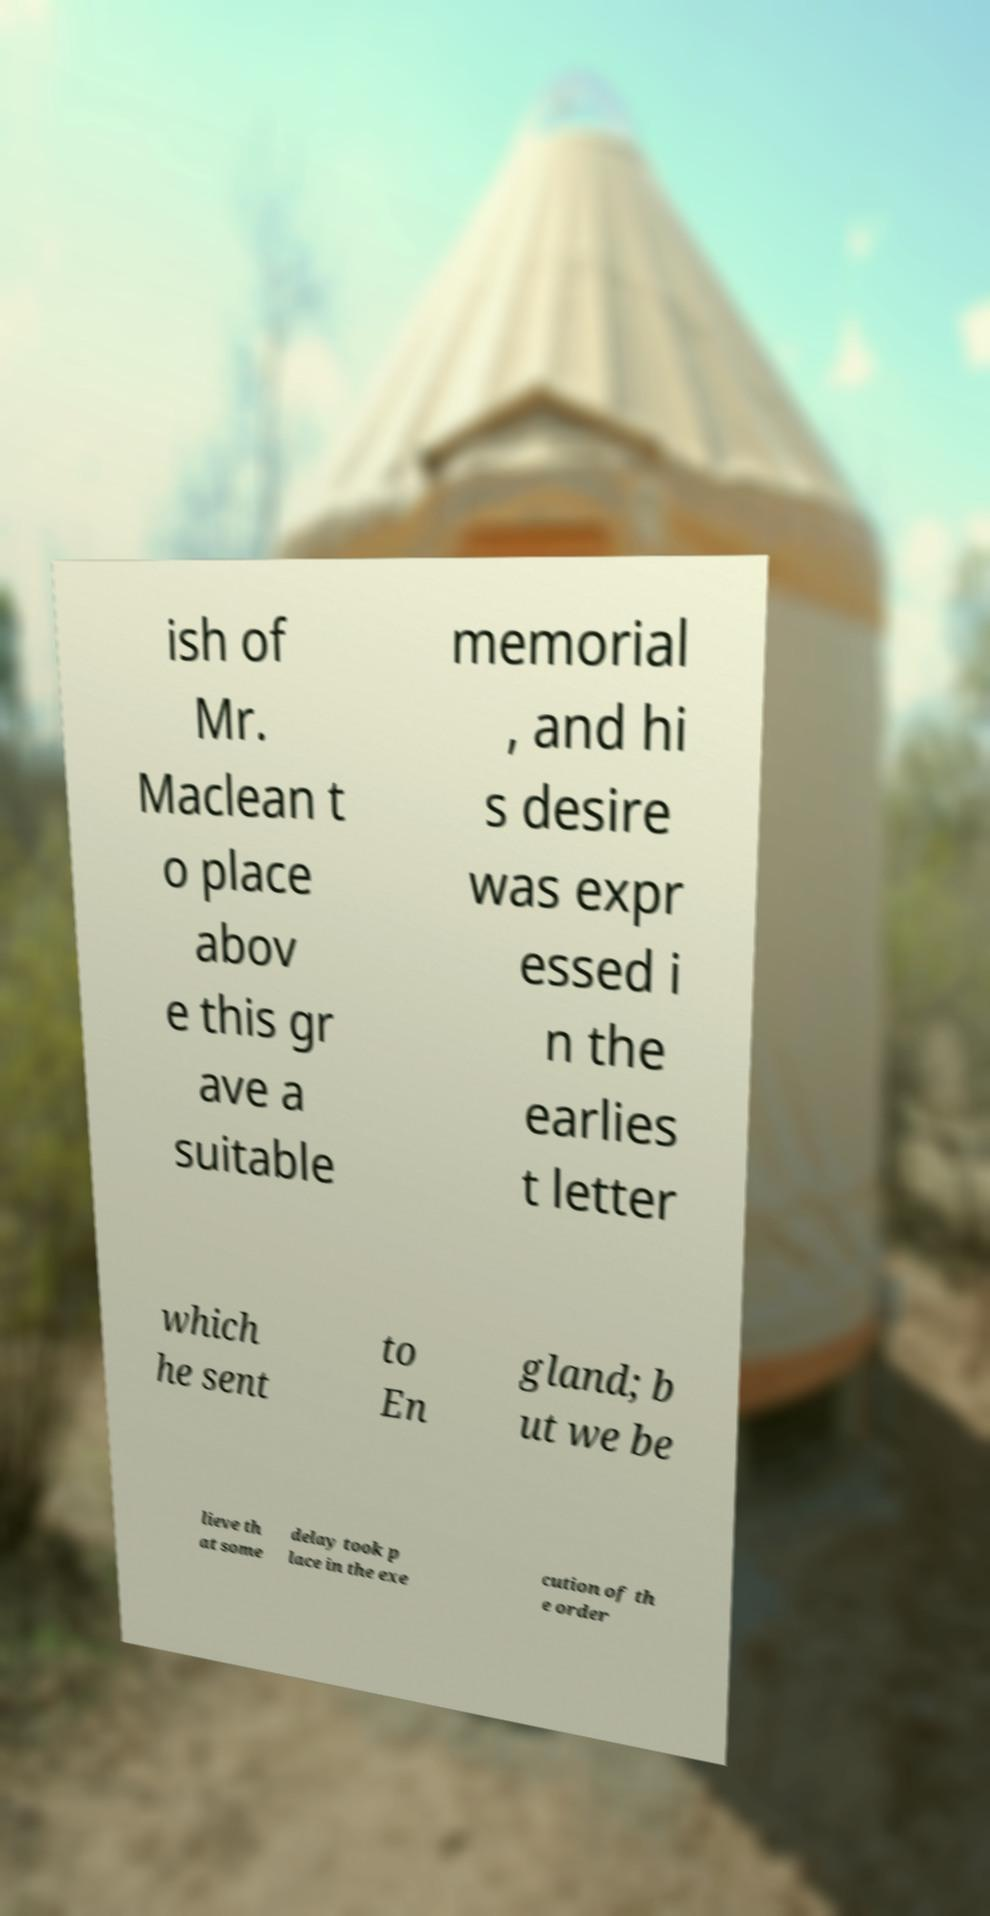What messages or text are displayed in this image? I need them in a readable, typed format. ish of Mr. Maclean t o place abov e this gr ave a suitable memorial , and hi s desire was expr essed i n the earlies t letter which he sent to En gland; b ut we be lieve th at some delay took p lace in the exe cution of th e order 